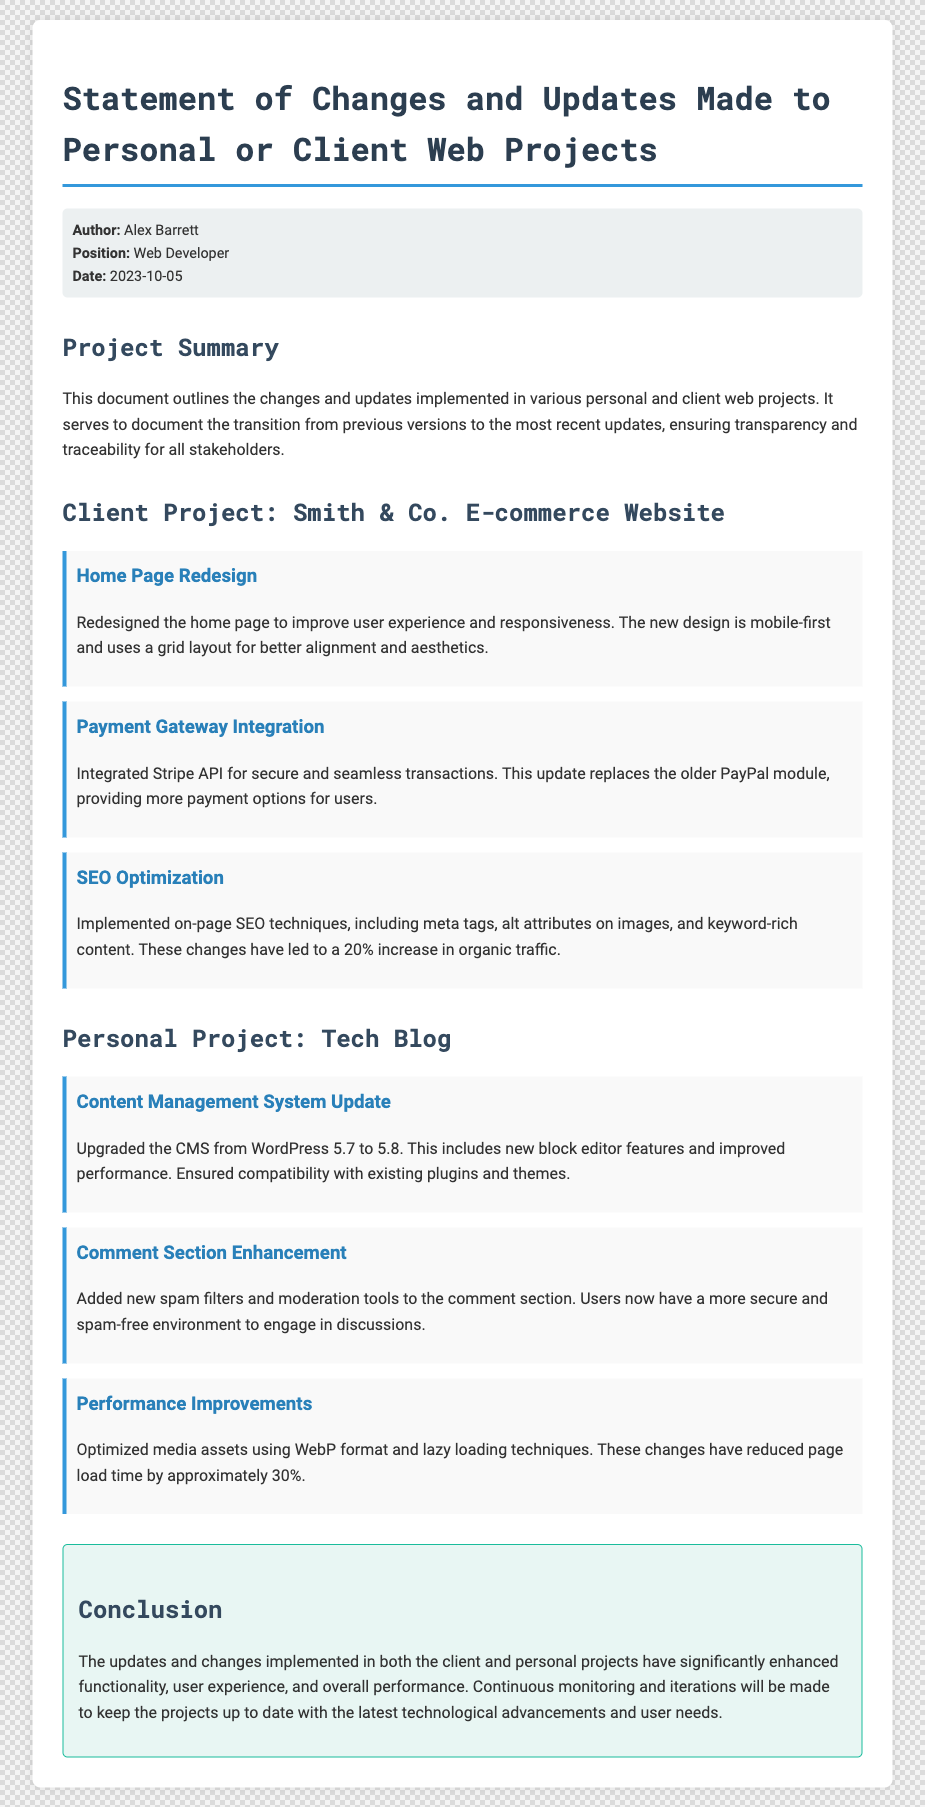What is the date of the document? The date is provided in the meta section of the document, which states “Date: 2023-10-05.”
Answer: 2023-10-05 Who is the author of the document? The author’s name is listed in the meta section as “Author: Alex Barrett.”
Answer: Alex Barrett What is the primary focus of the document? The primary focus is outlined in the summary section, which states the purpose of documenting changes and updates.
Answer: Changes and updates Which client project is mentioned in the document? The client project discussed is clearly labeled as “Client Project: Smith & Co. E-commerce Website.”
Answer: Smith & Co. E-commerce Website How much has organic traffic increased due to SEO optimization? The document specifies a percentage increase in organic traffic due to SEO changes.
Answer: 20% What significant payment integration was made? The document mentions the integration of a specific payment service in the context of payment updates.
Answer: Stripe API What type of project is the "Tech Blog"? The document categorizes this project type at the beginning of the section dedicated to it.
Answer: Personal Project What performance improvement technique was mentioned? The document refers to a specific technique used to optimize media assets for better performance.
Answer: WebP format How many changes are listed under the Smith & Co. project? The total number of changes made in this project is explicitly mentioned through counting the individual changes.
Answer: 3 What feature was added to enhance the comment section? The enhancements to the comment section are described, pointing to specific improvements made.
Answer: Spam filters 